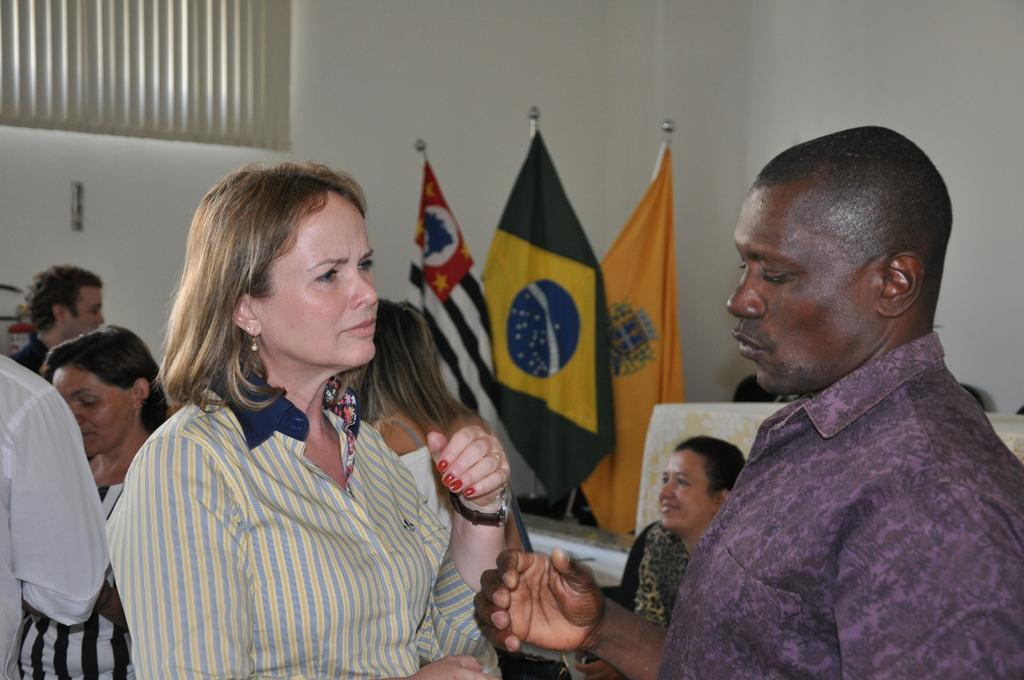What are the two people in the image doing? The two people in the image are standing and talking to each other. Can you describe the people behind them? There are other people behind them, but their actions or appearance cannot be determined from the provided facts. What can be seen in the image besides the people? There are flags visible in the image, and there is a white wall in the background. What type of fog can be seen in the image? There is no fog present in the image; it features two people talking and flags visible in the background. 